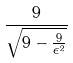<formula> <loc_0><loc_0><loc_500><loc_500>\frac { 9 } { \sqrt { 9 - \frac { 9 } { \epsilon ^ { 2 } } } }</formula> 